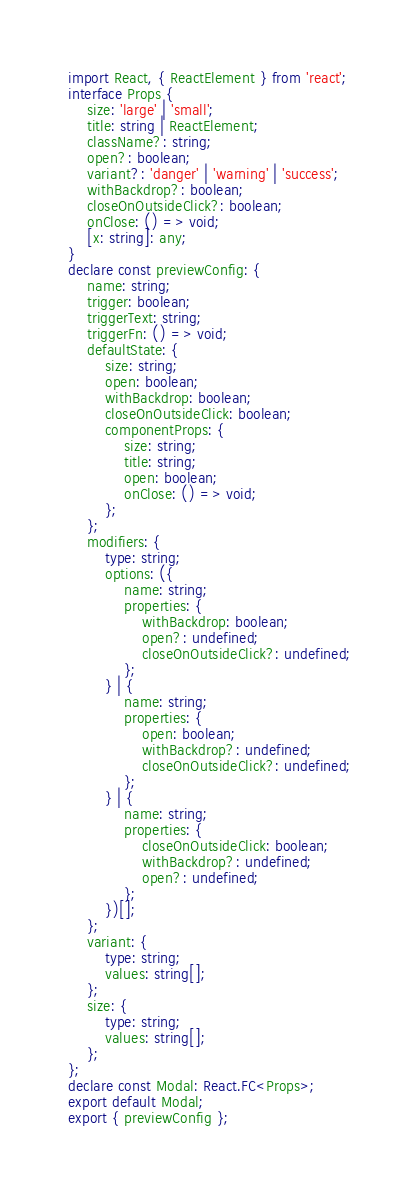<code> <loc_0><loc_0><loc_500><loc_500><_TypeScript_>import React, { ReactElement } from 'react';
interface Props {
    size: 'large' | 'small';
    title: string | ReactElement;
    className?: string;
    open?: boolean;
    variant?: 'danger' | 'warning' | 'success';
    withBackdrop?: boolean;
    closeOnOutsideClick?: boolean;
    onClose: () => void;
    [x: string]: any;
}
declare const previewConfig: {
    name: string;
    trigger: boolean;
    triggerText: string;
    triggerFn: () => void;
    defaultState: {
        size: string;
        open: boolean;
        withBackdrop: boolean;
        closeOnOutsideClick: boolean;
        componentProps: {
            size: string;
            title: string;
            open: boolean;
            onClose: () => void;
        };
    };
    modifiers: {
        type: string;
        options: ({
            name: string;
            properties: {
                withBackdrop: boolean;
                open?: undefined;
                closeOnOutsideClick?: undefined;
            };
        } | {
            name: string;
            properties: {
                open: boolean;
                withBackdrop?: undefined;
                closeOnOutsideClick?: undefined;
            };
        } | {
            name: string;
            properties: {
                closeOnOutsideClick: boolean;
                withBackdrop?: undefined;
                open?: undefined;
            };
        })[];
    };
    variant: {
        type: string;
        values: string[];
    };
    size: {
        type: string;
        values: string[];
    };
};
declare const Modal: React.FC<Props>;
export default Modal;
export { previewConfig };
</code> 